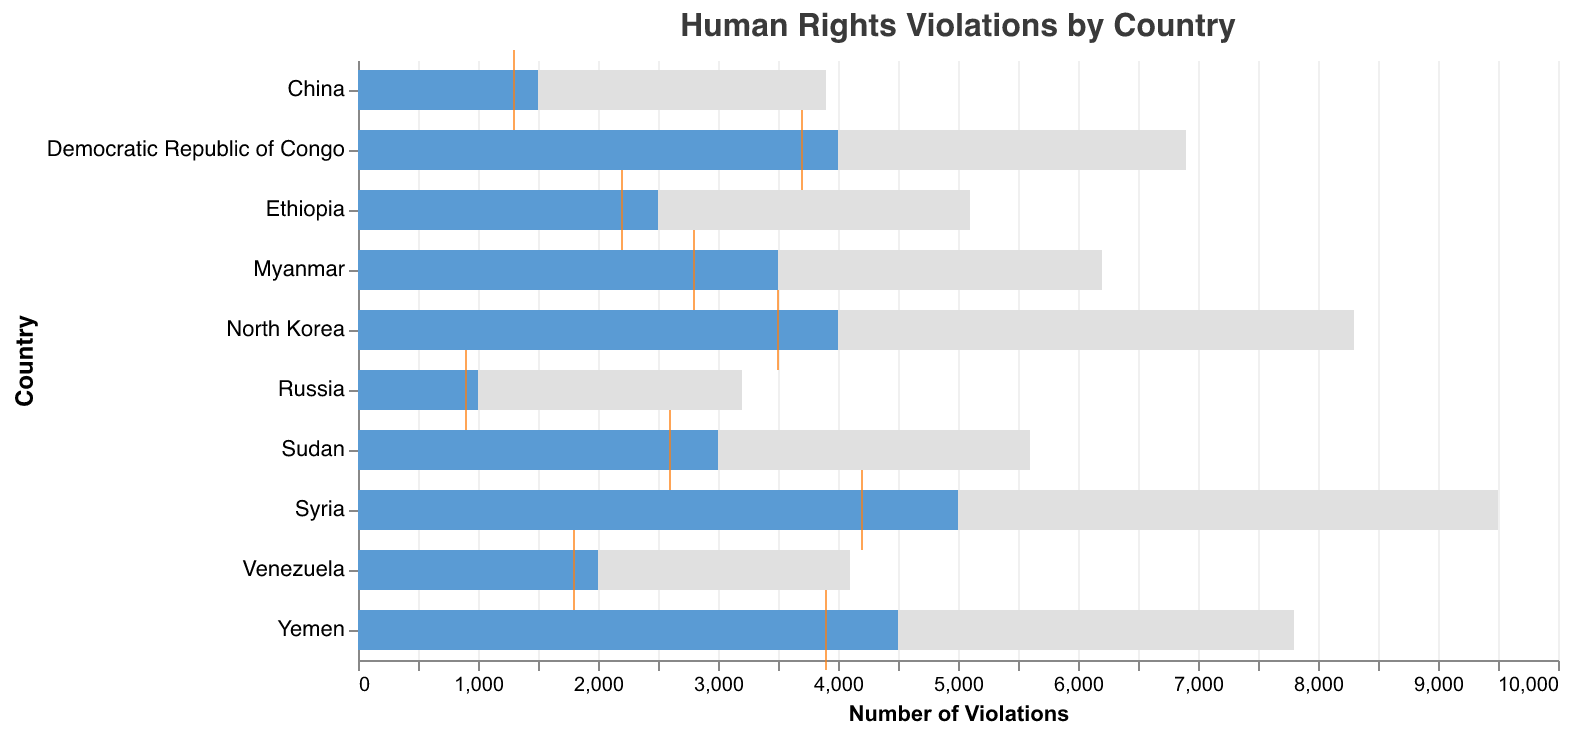What's the title of the figure? The title of the figure is shown at the top and specifies the main subject of the data. The title reads "Human Rights Violations by Country".
Answer: Human Rights Violations by Country What is the reported number of violations in Syria? By looking at the bar corresponding to Syria on the y-axis and the x-axis value, we can see that it reaches 9500.
Answer: 9500 Which country has the highest number of reported violations? Compare the lengths of the bars for each country; the longest bar corresponds to Syria.
Answer: Syria How does the reported number of violations in Myanmar compare to its UN Intervention Target? Myanmar's bar for reported violations is at 6200, and compared with the UN Intervention Target (the smaller blue bar) at 3500, it is higher by 2700.
Answer: Higher by 2700 What is the regional average of reported violations for North Korea? The regional average for North Korea is represented by an orange tick mark on the axis, which is labeled at 3500.
Answer: 3500 Compare the reported violations of Yemen with the regional average. Yemen's reported violations are at 7800, while the regional average, indicated by the orange tick, is 3900; thus, the reported violations in Yemen are higher by 3900.
Answer: Higher by 3900 Which countries have reported violations that exceed their UN Intervention Targets? Identify the countries where the grey bar extends beyond the blue bar: Syria, Myanmar, Yemen, Venezuela, North Korea, Sudan, China, Democratic Republic of Congo, and Ethiopia.
Answer: Syria, Myanmar, Yemen, Venezuela, North Korea, Sudan, China, Democratic Republic of Congo, Ethiopia How much higher is Venezuela's reported violations compared to its regional average? Venezuela's reported violations are at 4100, and the regional average is indicated by the orange tick at 1800. Thus, the difference is 4100 - 1800 = 2300.
Answer: 2300 What is the difference between the reported violations and UN Intervention Target for China? China's reported violations are 3900 compared to a UN Intervention Target of 1500, making a difference of 3900 - 1500 = 2400.
Answer: 2400 